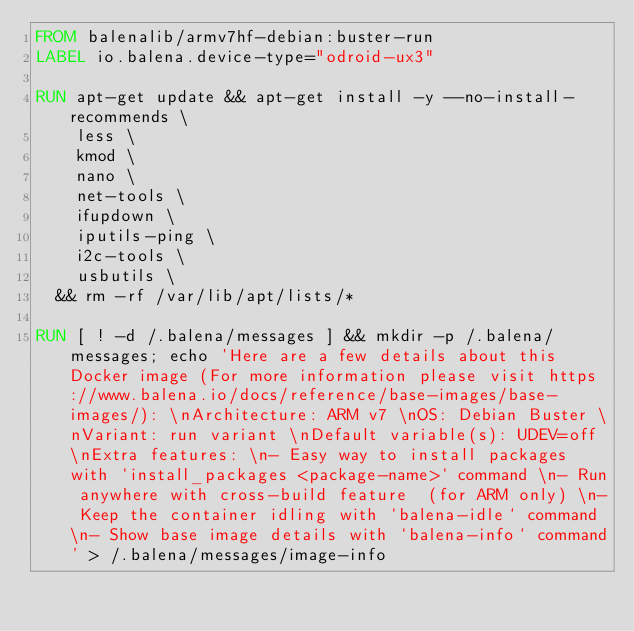<code> <loc_0><loc_0><loc_500><loc_500><_Dockerfile_>FROM balenalib/armv7hf-debian:buster-run
LABEL io.balena.device-type="odroid-ux3"

RUN apt-get update && apt-get install -y --no-install-recommends \
		less \
		kmod \
		nano \
		net-tools \
		ifupdown \
		iputils-ping \
		i2c-tools \
		usbutils \
	&& rm -rf /var/lib/apt/lists/*

RUN [ ! -d /.balena/messages ] && mkdir -p /.balena/messages; echo 'Here are a few details about this Docker image (For more information please visit https://www.balena.io/docs/reference/base-images/base-images/): \nArchitecture: ARM v7 \nOS: Debian Buster \nVariant: run variant \nDefault variable(s): UDEV=off \nExtra features: \n- Easy way to install packages with `install_packages <package-name>` command \n- Run anywhere with cross-build feature  (for ARM only) \n- Keep the container idling with `balena-idle` command \n- Show base image details with `balena-info` command' > /.balena/messages/image-info</code> 